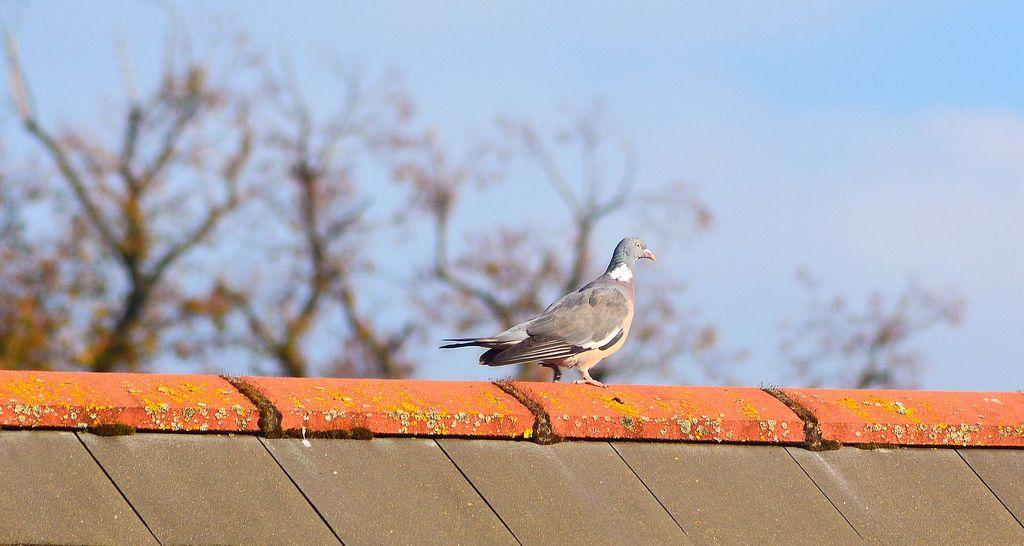What is on top of the house in the image? There is a bird on the house in the image. What type of vegetation can be seen in the image? There are trees in the image. What is visible in the background of the image? The sky is visible in the background of the image. How many balls are being used to hold up the cabbage in the image? There are no balls or cabbage present in the image. 